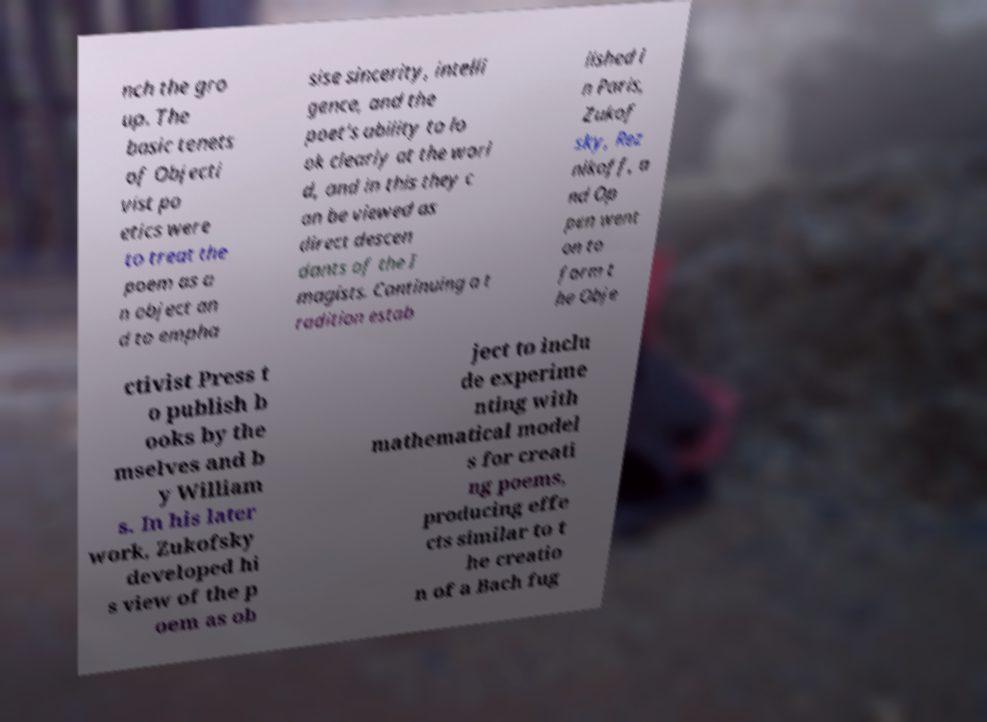What messages or text are displayed in this image? I need them in a readable, typed format. nch the gro up. The basic tenets of Objecti vist po etics were to treat the poem as a n object an d to empha sise sincerity, intelli gence, and the poet's ability to lo ok clearly at the worl d, and in this they c an be viewed as direct descen dants of the I magists. Continuing a t radition estab lished i n Paris, Zukof sky, Rez nikoff, a nd Op pen went on to form t he Obje ctivist Press t o publish b ooks by the mselves and b y William s. In his later work, Zukofsky developed hi s view of the p oem as ob ject to inclu de experime nting with mathematical model s for creati ng poems, producing effe cts similar to t he creatio n of a Bach fug 